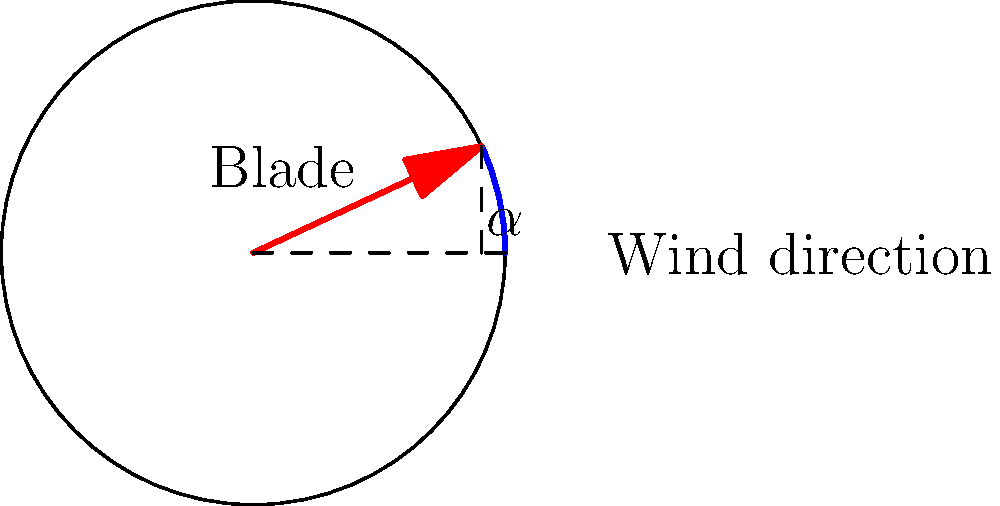For a custom-built wind turbine blade, you've determined that the optimal angle of attack ($\alpha$) for maximum power output is between 20° and 30°. Given that the power output (P) is related to the angle of attack by the equation $P = k \sin(2\alpha)$, where k is a constant, what is the exact angle of attack that maximizes power output? To find the angle of attack that maximizes power output, we need to follow these steps:

1) The power output is given by $P = k \sin(2\alpha)$, where $\alpha$ is in radians.

2) To find the maximum, we need to differentiate P with respect to $\alpha$ and set it to zero:

   $\frac{dP}{d\alpha} = 2k \cos(2\alpha) = 0$

3) Solving this equation:
   $\cos(2\alpha) = 0$
   
   This occurs when $2\alpha = \frac{\pi}{2}$ or $\frac{3\pi}{2}$

4) Since we're told the angle is between 20° and 30°, we can discard the $\frac{3\pi}{2}$ solution.

5) Solving for $\alpha$:
   $\alpha = \frac{\pi}{4} = 45°$

6) However, the question states that the angle is between 20° and 30°. This means the maximum within this range must occur at one of the endpoints.

7) Let's calculate the power at both endpoints:
   At 20°: $P = k \sin(40°) = 0.643k$
   At 30°: $P = k \sin(60°) = 0.866k$

8) Clearly, the power is higher at 30°.

Therefore, within the given range, the power output is maximized at an angle of attack of 30°.
Answer: 30° 